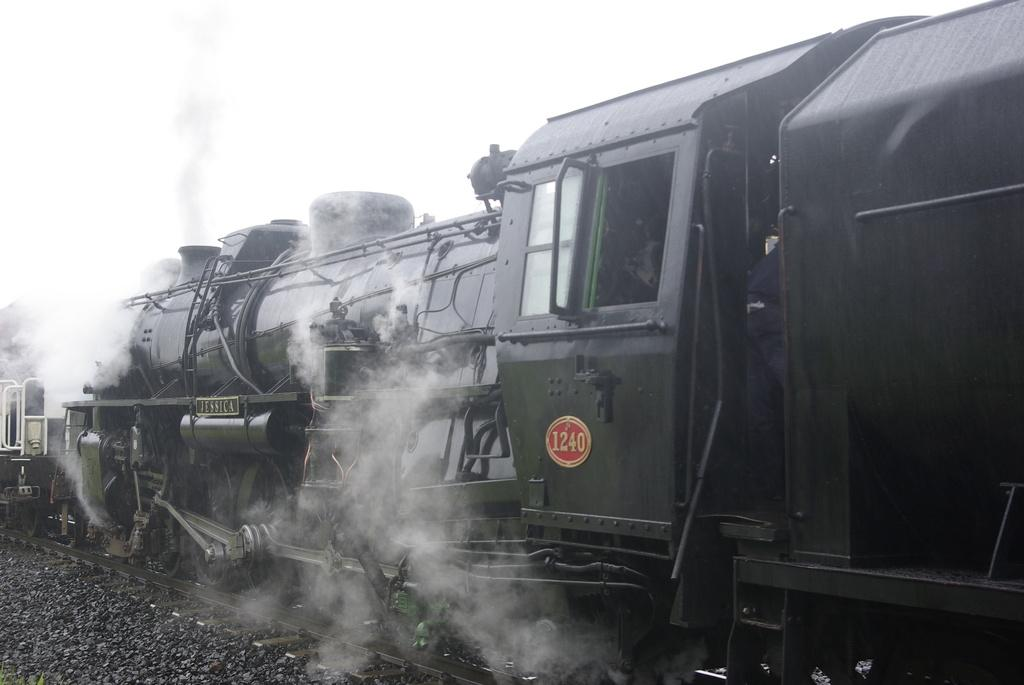What is the main subject of the image? The main subject of the image is a train. Where is the train located in the image? The train is on a railway track. What is visible at the top of the image? The sky is visible at the top of the image. Can you tell me how many kettles are on the train in the image? There is no kettle present on the train in the image. What direction is the train moving in the image? The image does not show the train moving, so it is not possible to determine the direction. 